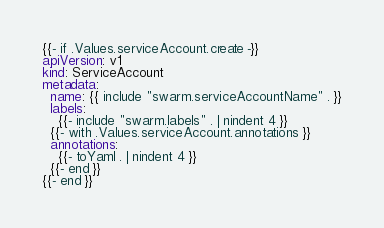Convert code to text. <code><loc_0><loc_0><loc_500><loc_500><_YAML_>{{- if .Values.serviceAccount.create -}}
apiVersion: v1
kind: ServiceAccount
metadata:
  name: {{ include "swarm.serviceAccountName" . }}
  labels:
    {{- include "swarm.labels" . | nindent 4 }}
  {{- with .Values.serviceAccount.annotations }}
  annotations:
    {{- toYaml . | nindent 4 }}
  {{- end }}
{{- end }}
</code> 